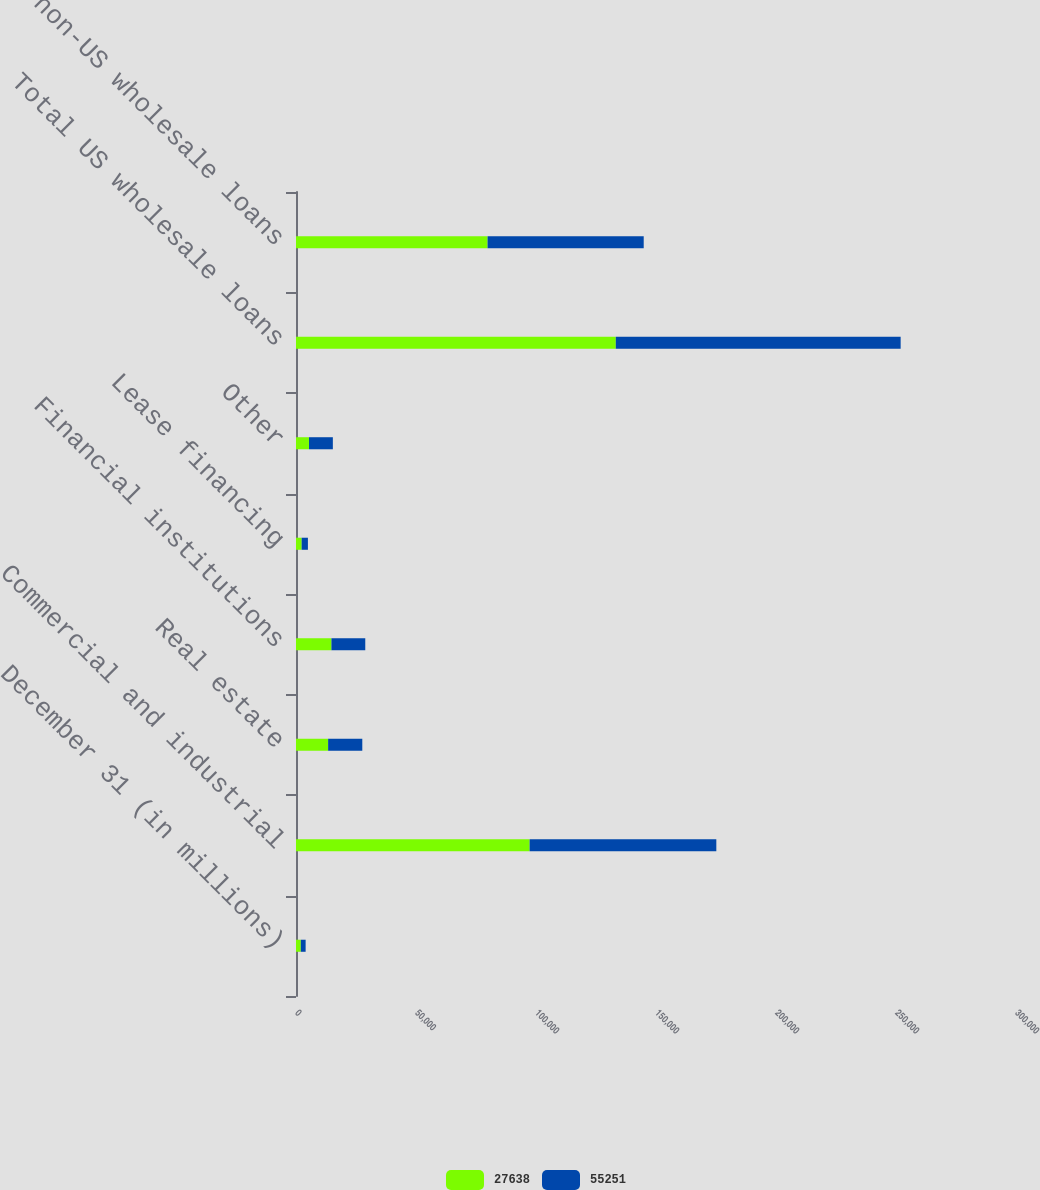<chart> <loc_0><loc_0><loc_500><loc_500><stacked_bar_chart><ecel><fcel>December 31 (in millions)<fcel>Commercial and industrial<fcel>Real estate<fcel>Financial institutions<fcel>Lease financing<fcel>Other<fcel>Total US wholesale loans<fcel>Total non-US wholesale loans<nl><fcel>27638<fcel>2007<fcel>97347<fcel>13388<fcel>14760<fcel>2353<fcel>5405<fcel>133253<fcel>79823<nl><fcel>55251<fcel>2006<fcel>77788<fcel>14237<fcel>14103<fcel>2608<fcel>9950<fcel>118686<fcel>65056<nl></chart> 